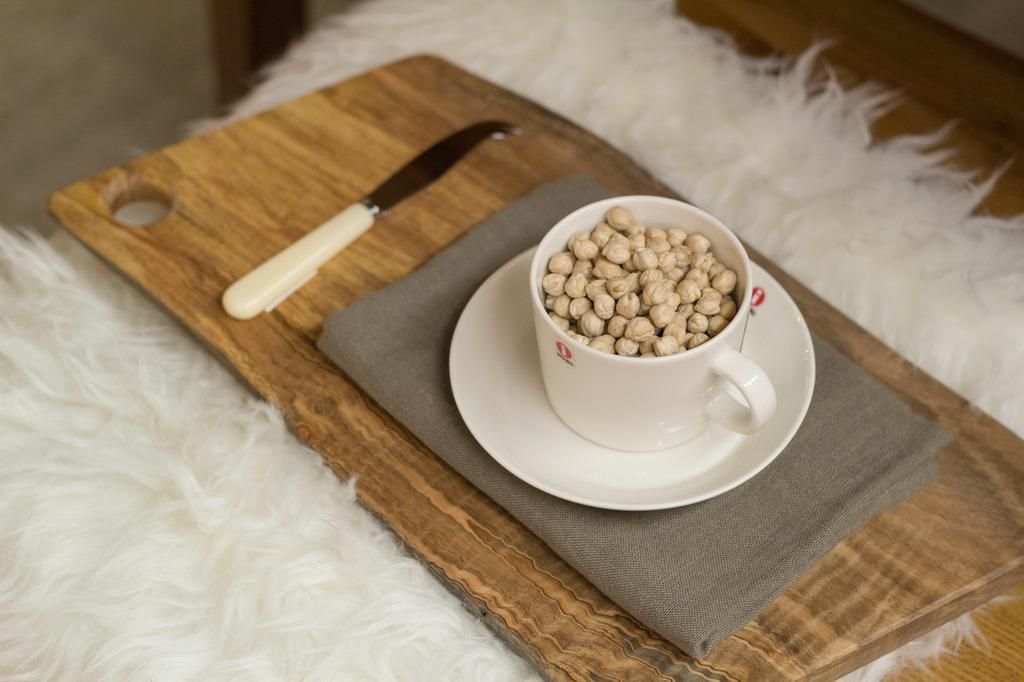What is inside the cup that is visible in the image? There is a cup full of chickpeas in the image. Where is the cup placed in the image? The cup is placed on a wooden table. What object is placed on top of the cup? A knife is on top of the cup. What type of surface is the cup and knife placed on? The objects are placed on a furry mat. What type of instrument is being played in the image? There is no instrument being played in the image; it only shows a cup full of chickpeas, a wooden table, a knife, and a furry mat. 